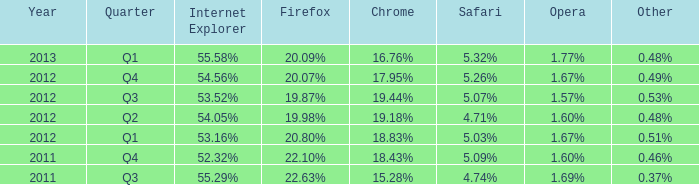What is the other that has 20.80% as the firefox? 0.51%. 